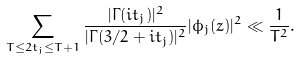<formula> <loc_0><loc_0><loc_500><loc_500>\sum _ { T \leq 2 t _ { j } \leq T + 1 } \frac { | \Gamma ( i t _ { j } ) | ^ { 2 } } { | \Gamma ( 3 / 2 + i t _ { j } ) | ^ { 2 } } | \phi _ { j } ( z ) | ^ { 2 } \ll \frac { 1 } { T ^ { 2 } } .</formula> 